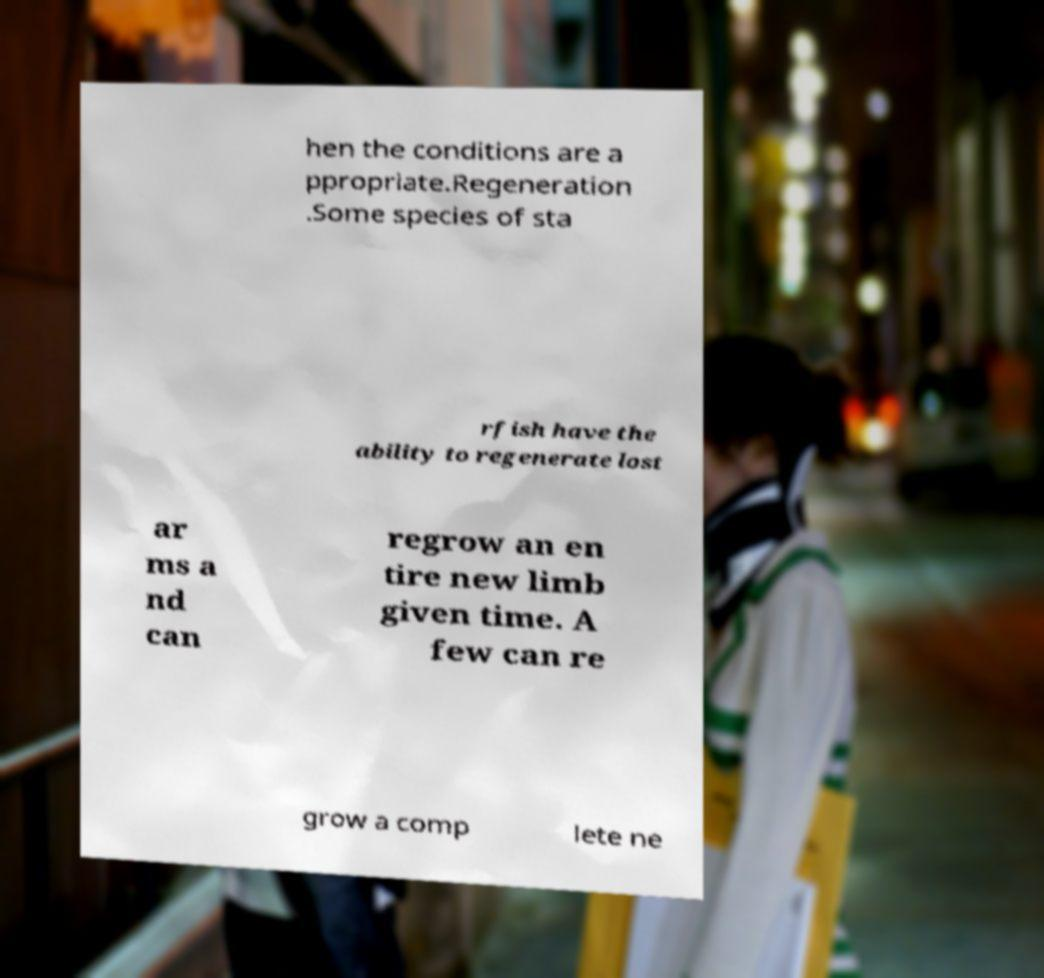Could you assist in decoding the text presented in this image and type it out clearly? hen the conditions are a ppropriate.Regeneration .Some species of sta rfish have the ability to regenerate lost ar ms a nd can regrow an en tire new limb given time. A few can re grow a comp lete ne 